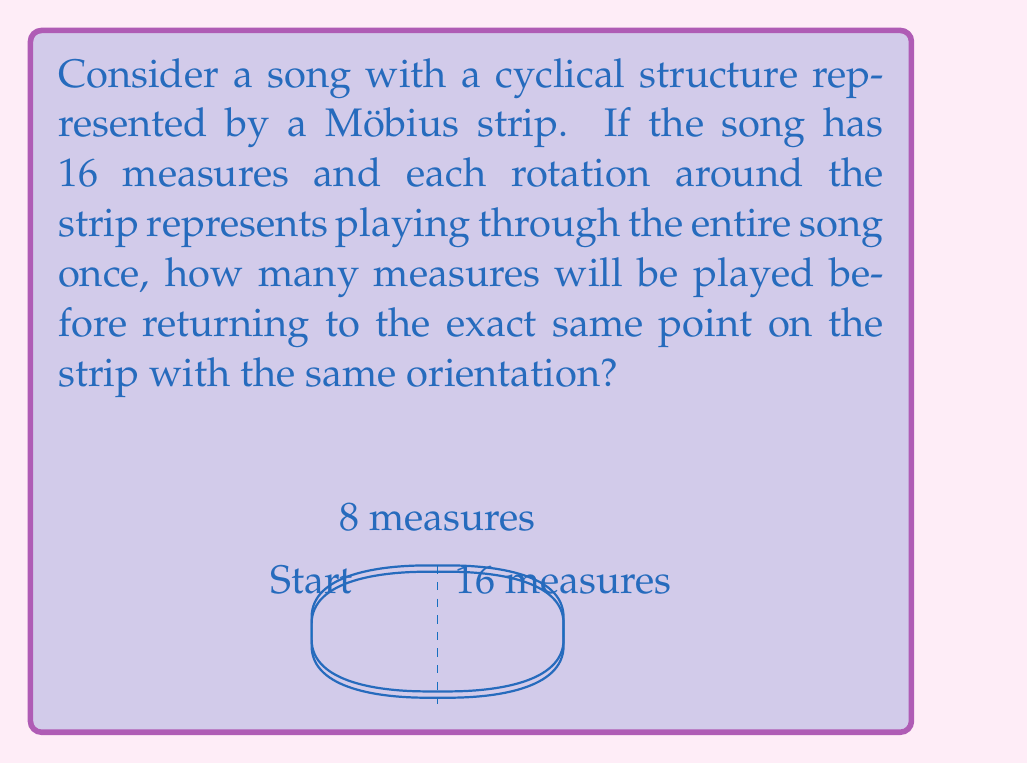Can you answer this question? Let's approach this step-by-step:

1) A Möbius strip has the unique property of having only one side and one edge. When you trace a path along the center of a Möbius strip, you return to your starting point after traversing twice the length of the strip.

2) In this case, one complete rotation around the strip represents playing through the entire 16-measure song once.

3) However, due to the twist in the Möbius strip, after one complete rotation (16 measures), you'll be on the "opposite" side of where you started.

4) To return to the exact same point with the same orientation, you need to complete two full rotations of the strip.

5) Mathematically, this can be represented as:

   $$\text{Total measures} = \text{Measures per rotation} \times \text{Number of rotations}$$
   $$\text{Total measures} = 16 \times 2 = 32$$

6) This cyclical structure creates an interesting effect in music, where the song can seamlessly loop back on itself, creating a continuous, potentially infinite composition.
Answer: 32 measures 